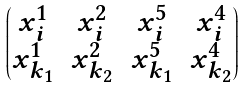Convert formula to latex. <formula><loc_0><loc_0><loc_500><loc_500>\begin{pmatrix} x _ { i } ^ { 1 } & x _ { i } ^ { 2 } & x _ { i } ^ { 5 } & x _ { i } ^ { 4 } \\ x _ { k _ { 1 } } ^ { 1 } & x _ { k _ { 2 } } ^ { 2 } & x _ { k _ { 1 } } ^ { 5 } & x _ { k _ { 2 } } ^ { 4 } \end{pmatrix}</formula> 